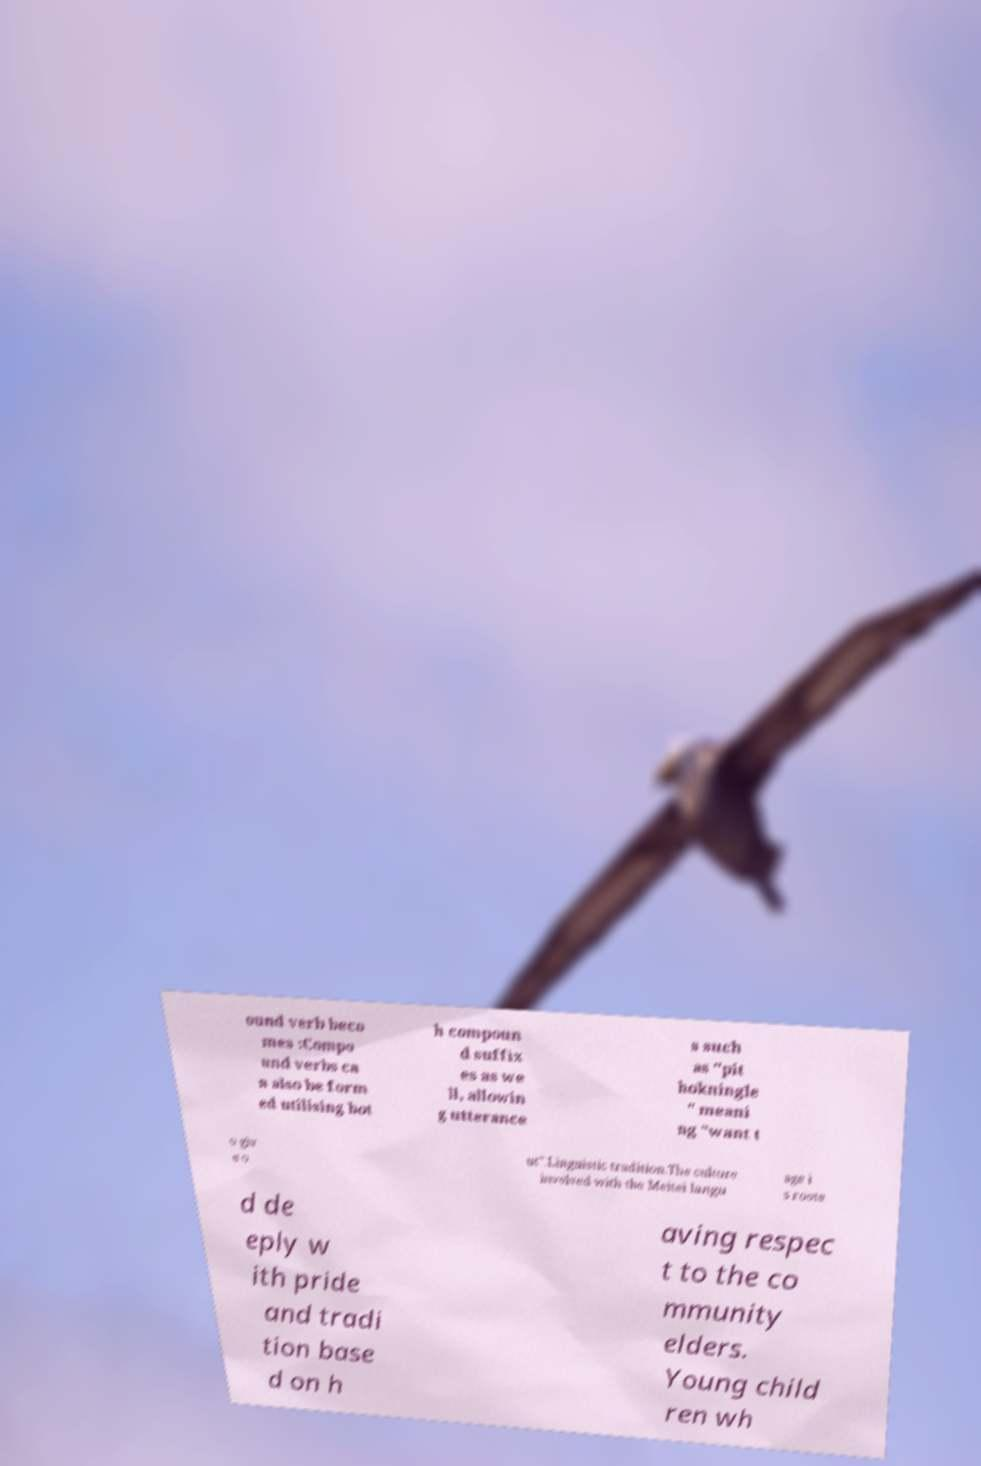Please read and relay the text visible in this image. What does it say? ound verb beco mes :Compo und verbs ca n also be form ed utilising bot h compoun d suffix es as we ll, allowin g utterance s such as "pit hokningle " meani ng "want t o giv e o ut".Linguistic tradition.The culture involved with the Meitei langu age i s roote d de eply w ith pride and tradi tion base d on h aving respec t to the co mmunity elders. Young child ren wh 